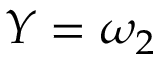Convert formula to latex. <formula><loc_0><loc_0><loc_500><loc_500>Y = \omega _ { 2 }</formula> 